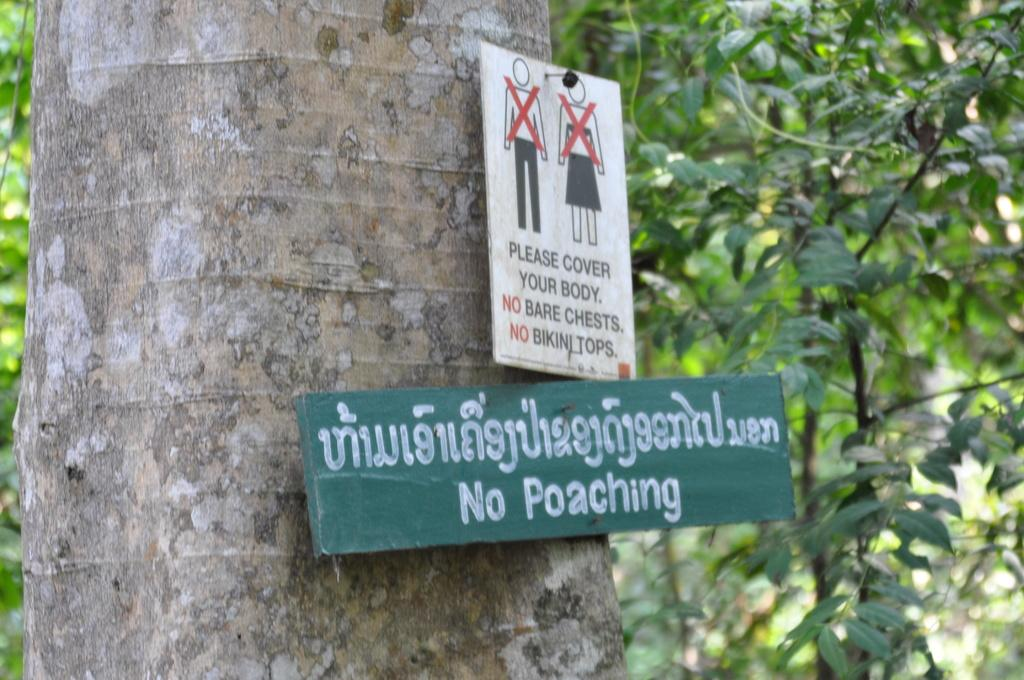What type of vegetation can be seen in the image? There are trees in the image. What is attached to the trees in the image? Information boards are attached to the trees in the image. What type of meat is being cooked on the grill in the image? There is no grill or meat present in the image; it only features trees with information boards attached. 